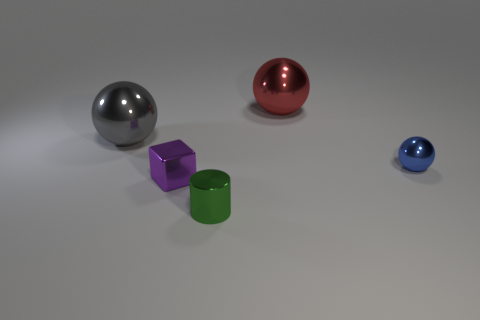What shape is the tiny blue shiny object?
Your answer should be very brief. Sphere. What number of other cubes are made of the same material as the purple cube?
Provide a succinct answer. 0. What color is the other big ball that is made of the same material as the red ball?
Your answer should be very brief. Gray. Do the red sphere and the sphere to the left of the small block have the same size?
Give a very brief answer. Yes. What number of objects are tiny green things or big gray metallic balls?
Ensure brevity in your answer.  2. There is a purple object that is the same size as the green thing; what shape is it?
Make the answer very short. Cube. What number of things are big metal objects that are left of the large red shiny object or small objects in front of the blue metallic object?
Your answer should be compact. 3. Is the number of big yellow matte blocks less than the number of purple blocks?
Keep it short and to the point. Yes. There is a purple thing that is the same size as the blue metallic thing; what is it made of?
Ensure brevity in your answer.  Metal. Do the metallic ball right of the big red shiny sphere and the thing to the left of the purple block have the same size?
Ensure brevity in your answer.  No. 